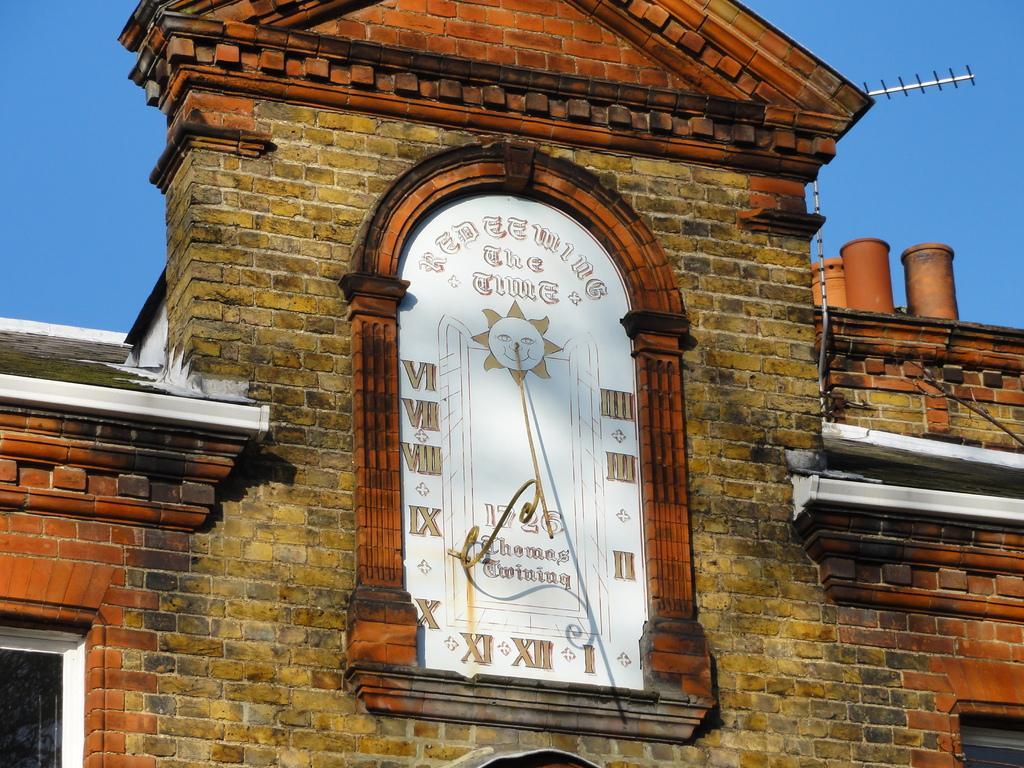<image>
Summarize the visual content of the image. a clock with words Red EE Wing has a sun and is on a brick facade 